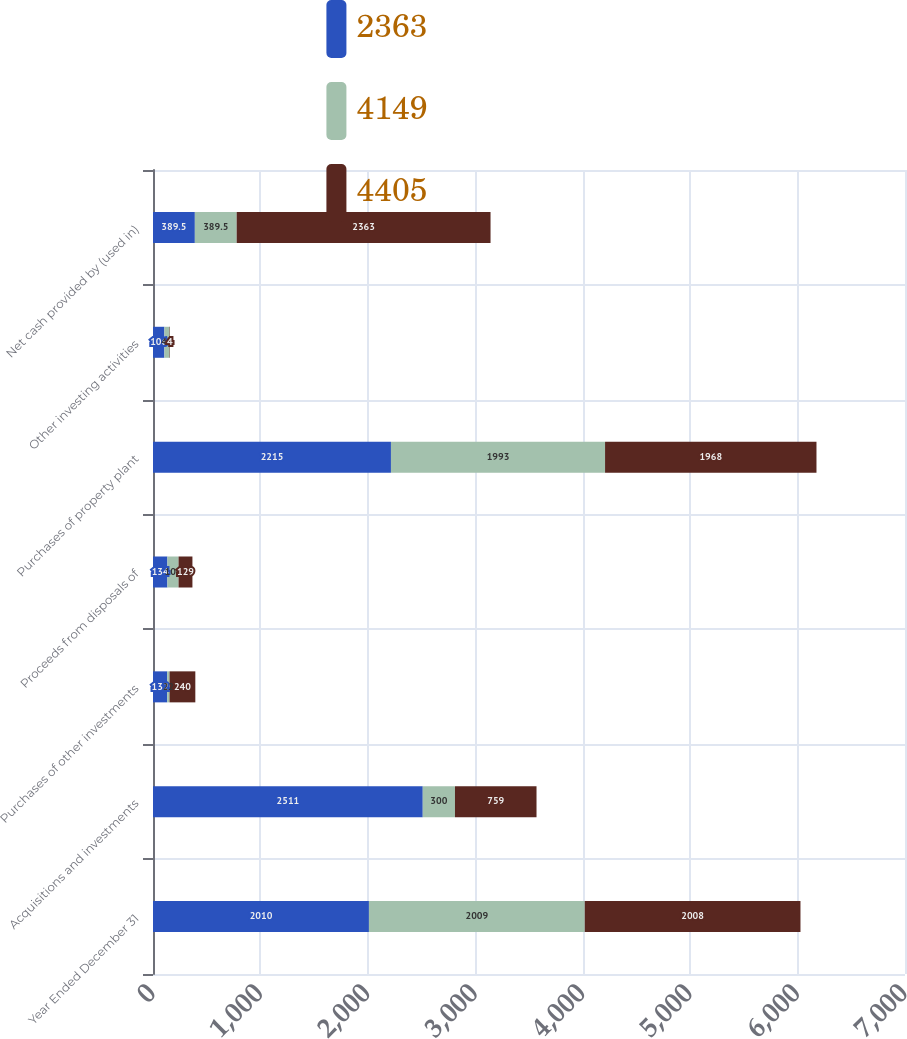Convert chart to OTSL. <chart><loc_0><loc_0><loc_500><loc_500><stacked_bar_chart><ecel><fcel>Year Ended December 31<fcel>Acquisitions and investments<fcel>Purchases of other investments<fcel>Proceeds from disposals of<fcel>Purchases of property plant<fcel>Other investing activities<fcel>Net cash provided by (used in)<nl><fcel>2363<fcel>2010<fcel>2511<fcel>132<fcel>134<fcel>2215<fcel>106<fcel>389.5<nl><fcel>4149<fcel>2009<fcel>300<fcel>22<fcel>104<fcel>1993<fcel>48<fcel>389.5<nl><fcel>4405<fcel>2008<fcel>759<fcel>240<fcel>129<fcel>1968<fcel>4<fcel>2363<nl></chart> 